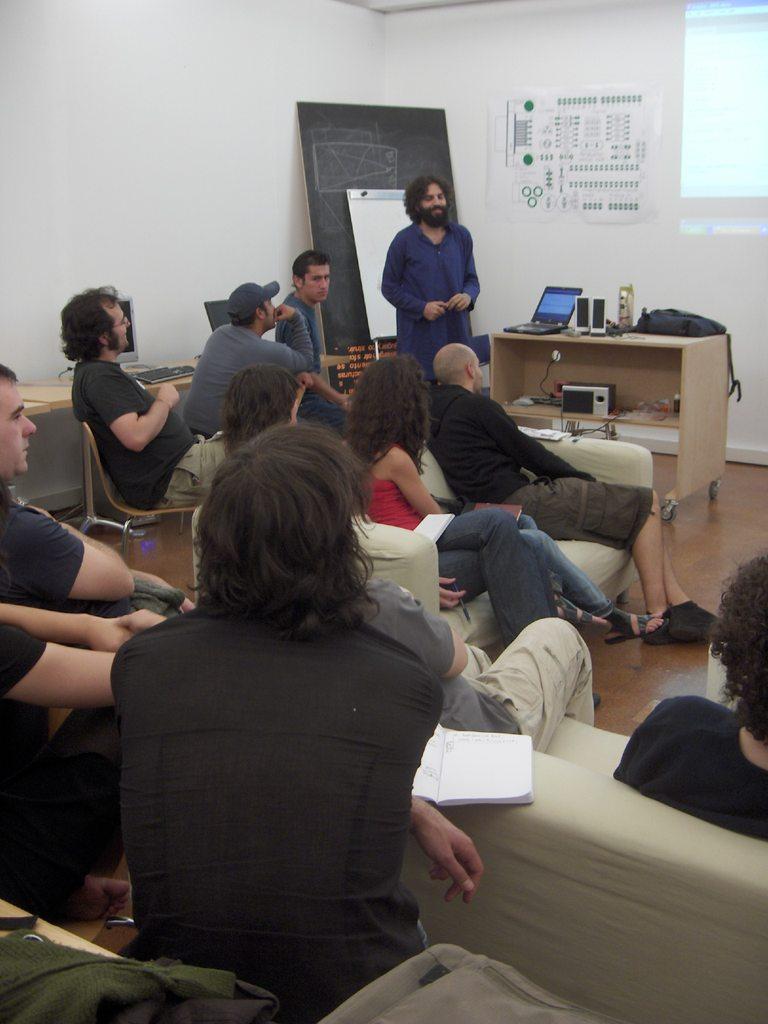Describe this image in one or two sentences. in this picture we can see people sitting on the chair and sofa here we can see a person standing and talking to them,here we can see a black board ,here we can see a laptop on the table. 